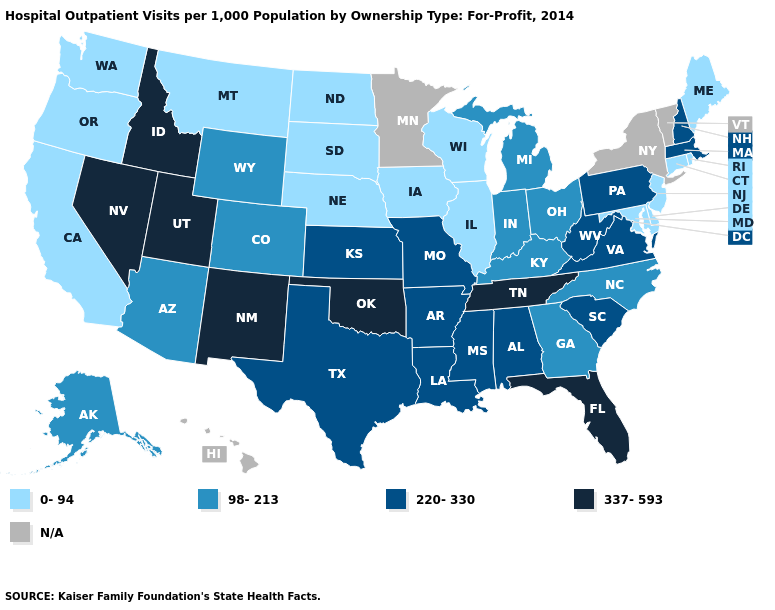Which states have the highest value in the USA?
Short answer required. Florida, Idaho, Nevada, New Mexico, Oklahoma, Tennessee, Utah. What is the lowest value in the Northeast?
Concise answer only. 0-94. Name the states that have a value in the range 98-213?
Answer briefly. Alaska, Arizona, Colorado, Georgia, Indiana, Kentucky, Michigan, North Carolina, Ohio, Wyoming. What is the value of New Mexico?
Give a very brief answer. 337-593. Does the map have missing data?
Write a very short answer. Yes. What is the value of Tennessee?
Write a very short answer. 337-593. What is the value of New York?
Give a very brief answer. N/A. Name the states that have a value in the range 220-330?
Keep it brief. Alabama, Arkansas, Kansas, Louisiana, Massachusetts, Mississippi, Missouri, New Hampshire, Pennsylvania, South Carolina, Texas, Virginia, West Virginia. What is the lowest value in the South?
Be succinct. 0-94. Name the states that have a value in the range N/A?
Give a very brief answer. Hawaii, Minnesota, New York, Vermont. Does the map have missing data?
Give a very brief answer. Yes. Which states have the lowest value in the MidWest?
Keep it brief. Illinois, Iowa, Nebraska, North Dakota, South Dakota, Wisconsin. What is the value of South Carolina?
Answer briefly. 220-330. Which states have the lowest value in the Northeast?
Give a very brief answer. Connecticut, Maine, New Jersey, Rhode Island. 